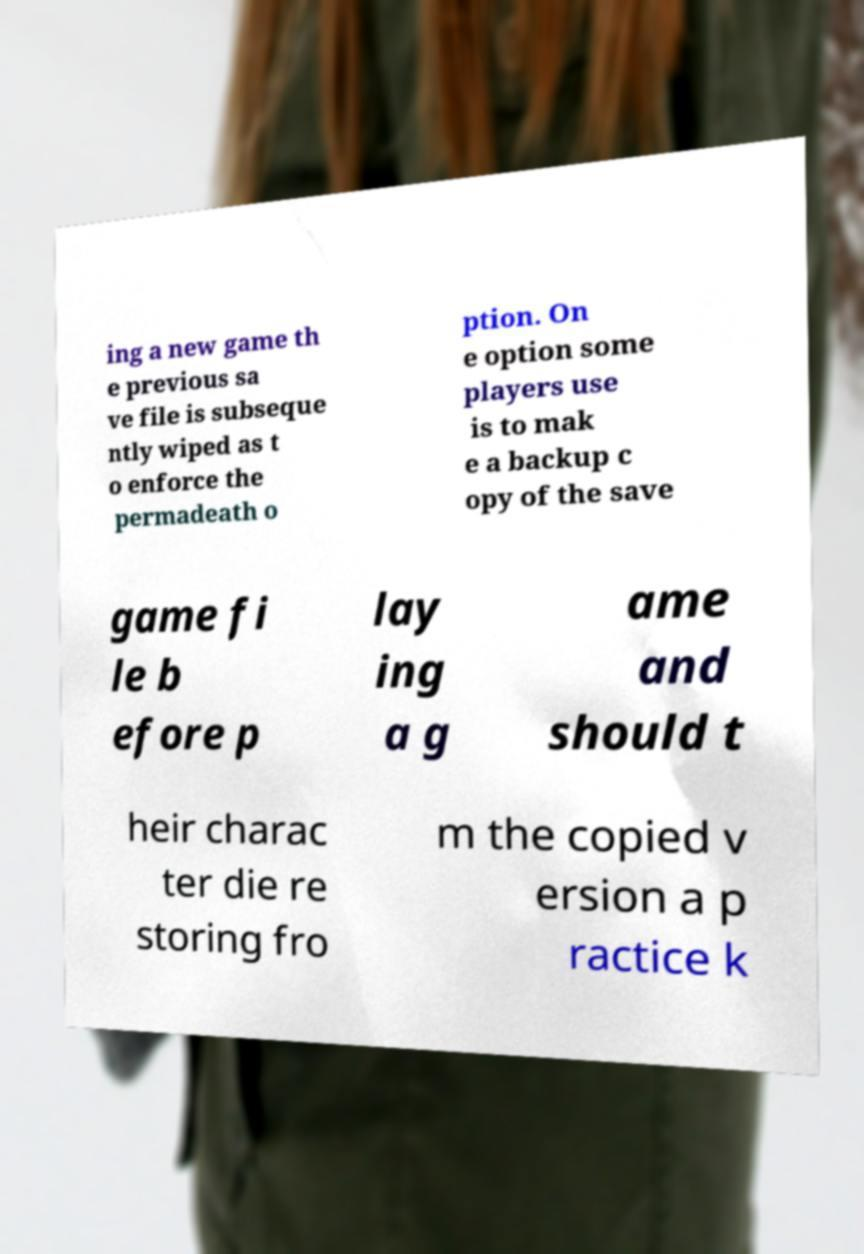For documentation purposes, I need the text within this image transcribed. Could you provide that? ing a new game th e previous sa ve file is subseque ntly wiped as t o enforce the permadeath o ption. On e option some players use is to mak e a backup c opy of the save game fi le b efore p lay ing a g ame and should t heir charac ter die re storing fro m the copied v ersion a p ractice k 